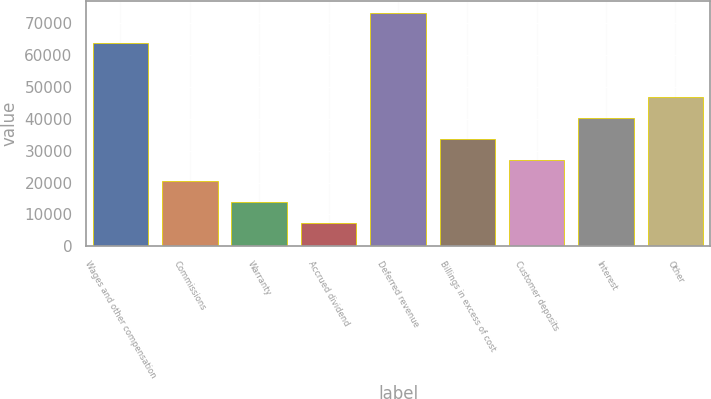Convert chart to OTSL. <chart><loc_0><loc_0><loc_500><loc_500><bar_chart><fcel>Wages and other compensation<fcel>Commissions<fcel>Warranty<fcel>Accrued dividend<fcel>Deferred revenue<fcel>Billings in excess of cost<fcel>Customer deposits<fcel>Interest<fcel>Other<nl><fcel>63878<fcel>20584<fcel>13993.5<fcel>7403<fcel>73308<fcel>33765<fcel>27174.5<fcel>40355.5<fcel>46946<nl></chart> 